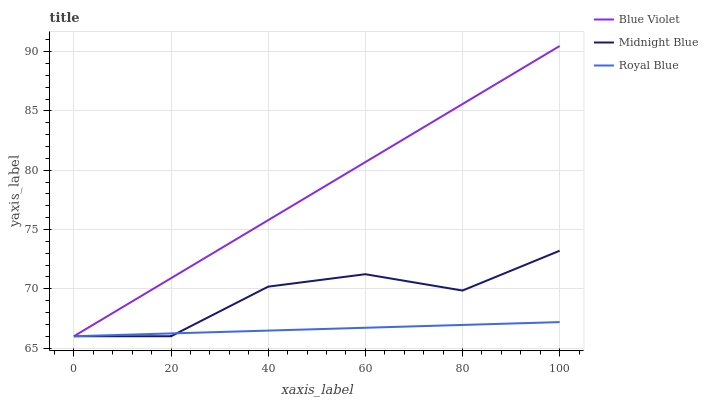Does Royal Blue have the minimum area under the curve?
Answer yes or no. Yes. Does Blue Violet have the maximum area under the curve?
Answer yes or no. Yes. Does Midnight Blue have the minimum area under the curve?
Answer yes or no. No. Does Midnight Blue have the maximum area under the curve?
Answer yes or no. No. Is Royal Blue the smoothest?
Answer yes or no. Yes. Is Midnight Blue the roughest?
Answer yes or no. Yes. Is Blue Violet the smoothest?
Answer yes or no. No. Is Blue Violet the roughest?
Answer yes or no. No. Does Royal Blue have the lowest value?
Answer yes or no. Yes. Does Blue Violet have the highest value?
Answer yes or no. Yes. Does Midnight Blue have the highest value?
Answer yes or no. No. Does Royal Blue intersect Blue Violet?
Answer yes or no. Yes. Is Royal Blue less than Blue Violet?
Answer yes or no. No. Is Royal Blue greater than Blue Violet?
Answer yes or no. No. 